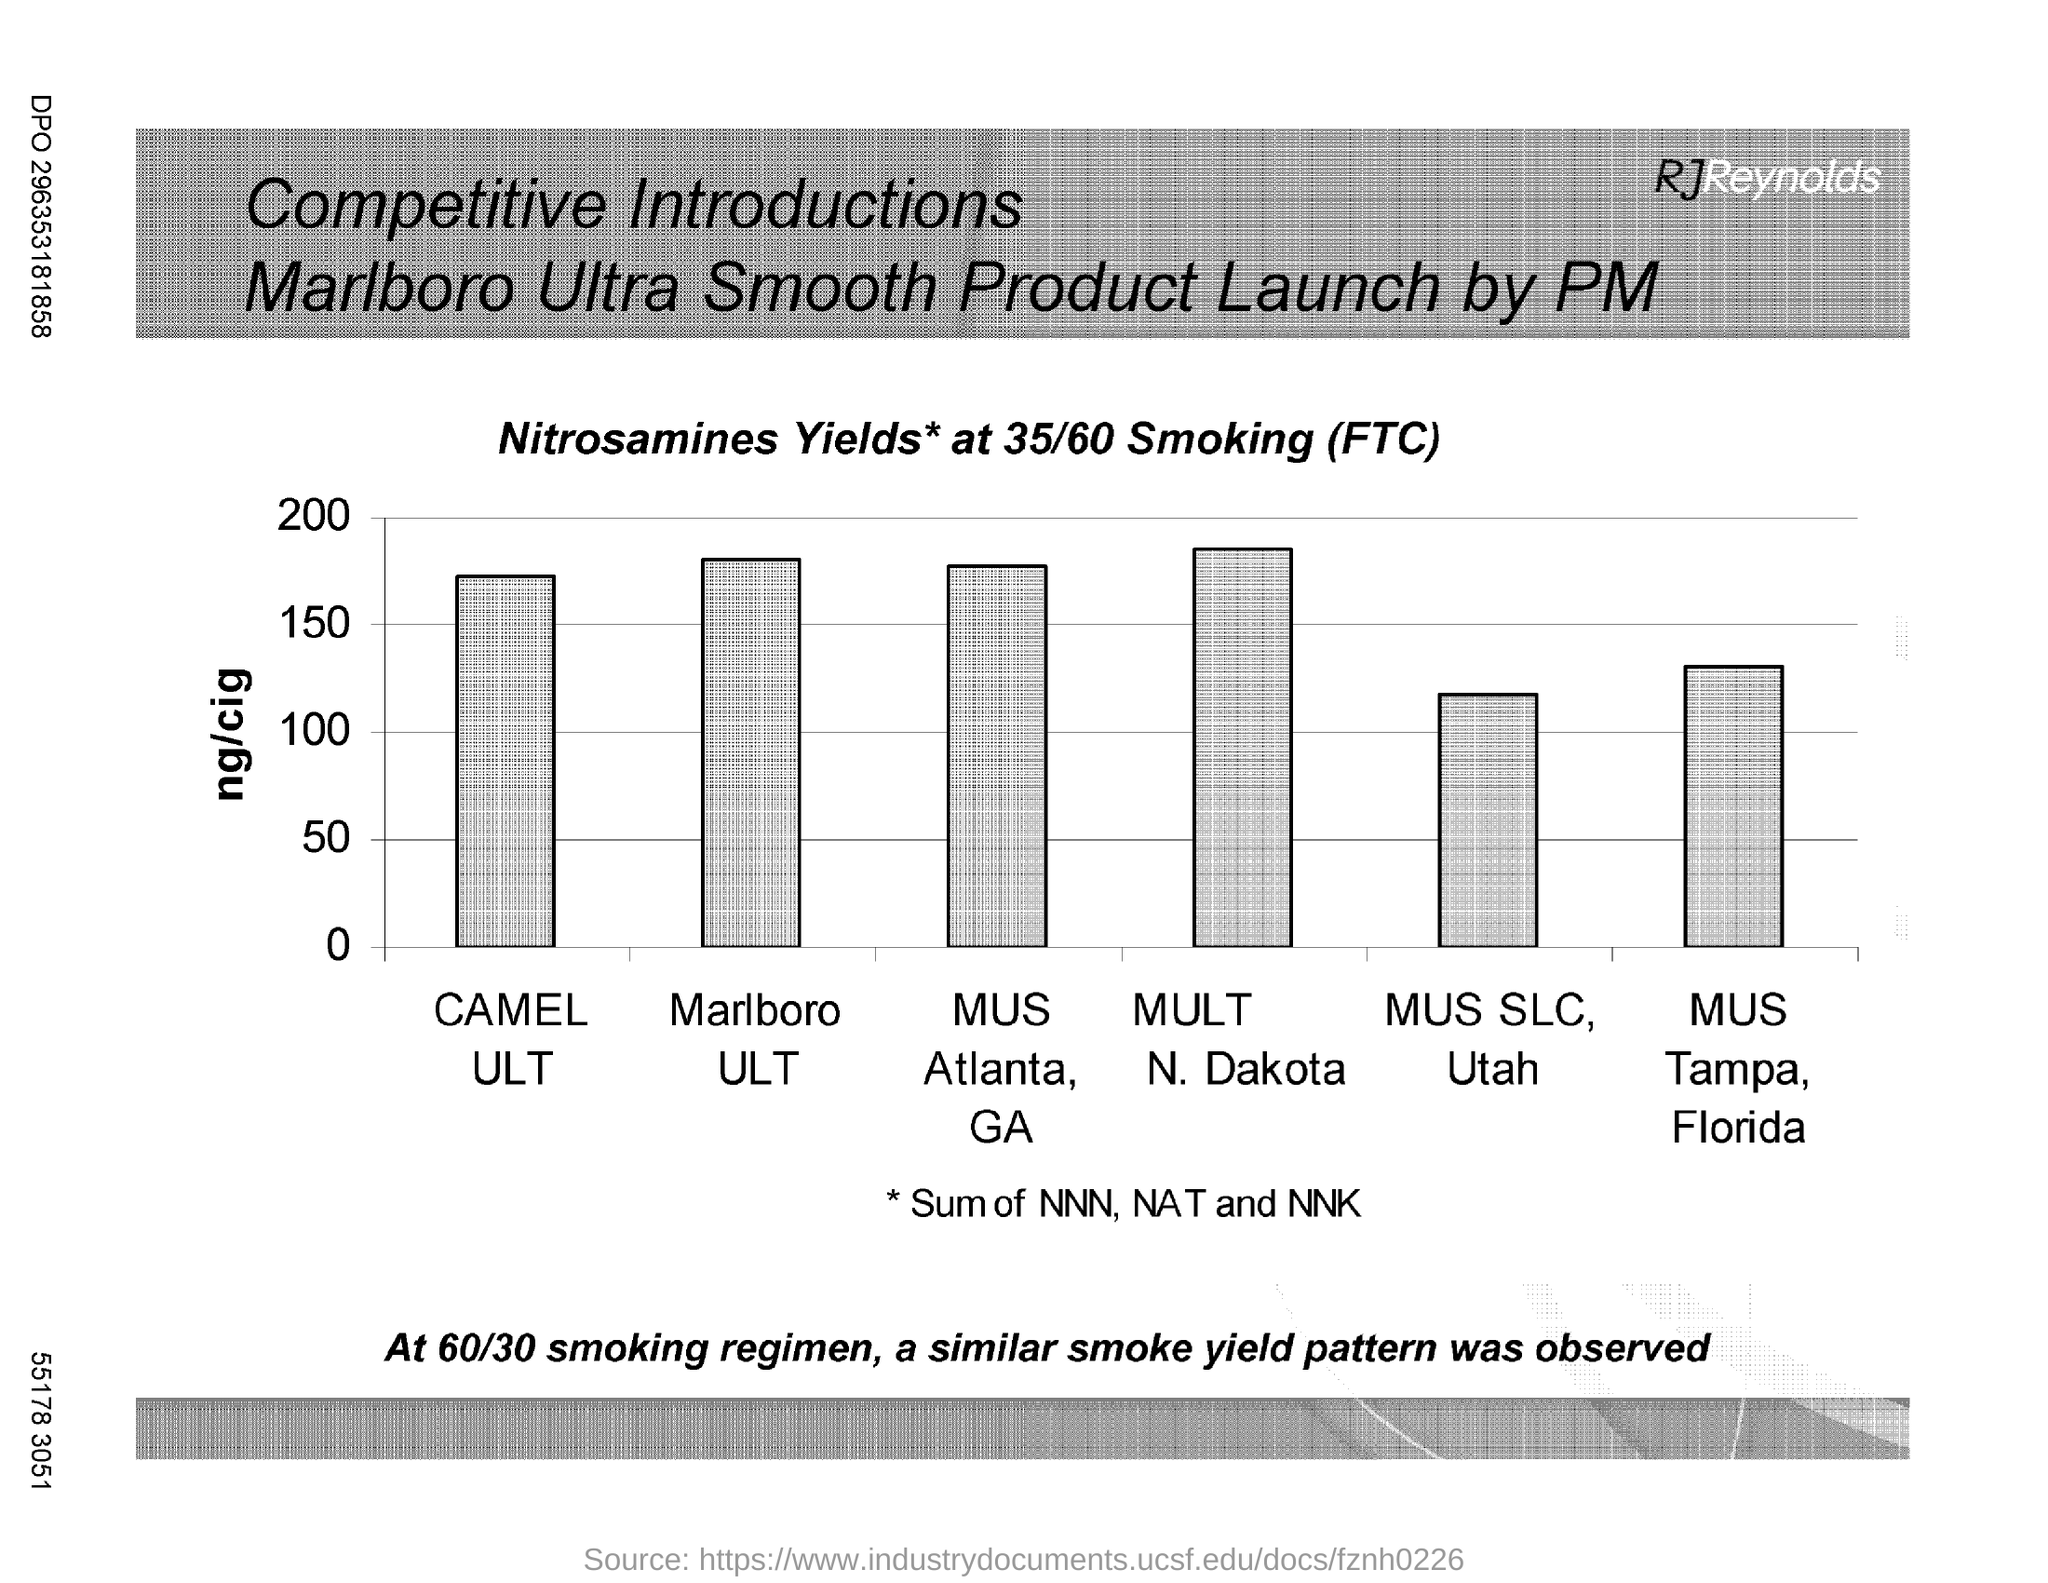Which product has the highest ng/cig?
Give a very brief answer. MULT N. DAKOTA. 